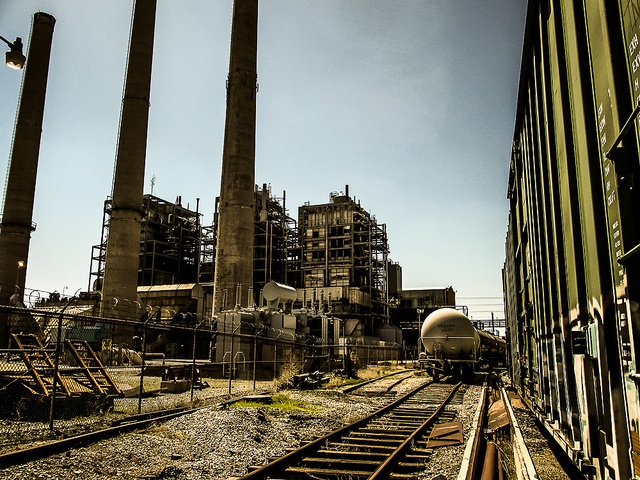Describe the objects in this image and their specific colors. I can see train in gray, black, olive, and khaki tones and train in gray, black, olive, and ivory tones in this image. 